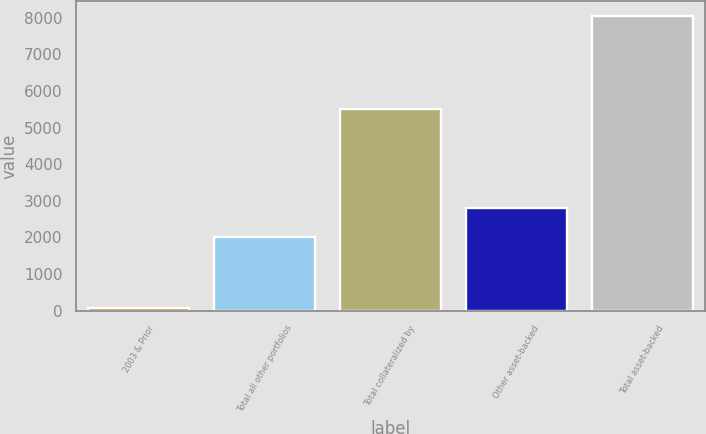<chart> <loc_0><loc_0><loc_500><loc_500><bar_chart><fcel>2003 & Prior<fcel>Total all other portfolios<fcel>Total collateralized by<fcel>Other asset-backed<fcel>Total asset-backed<nl><fcel>63<fcel>2014<fcel>5515<fcel>2813.2<fcel>8055<nl></chart> 